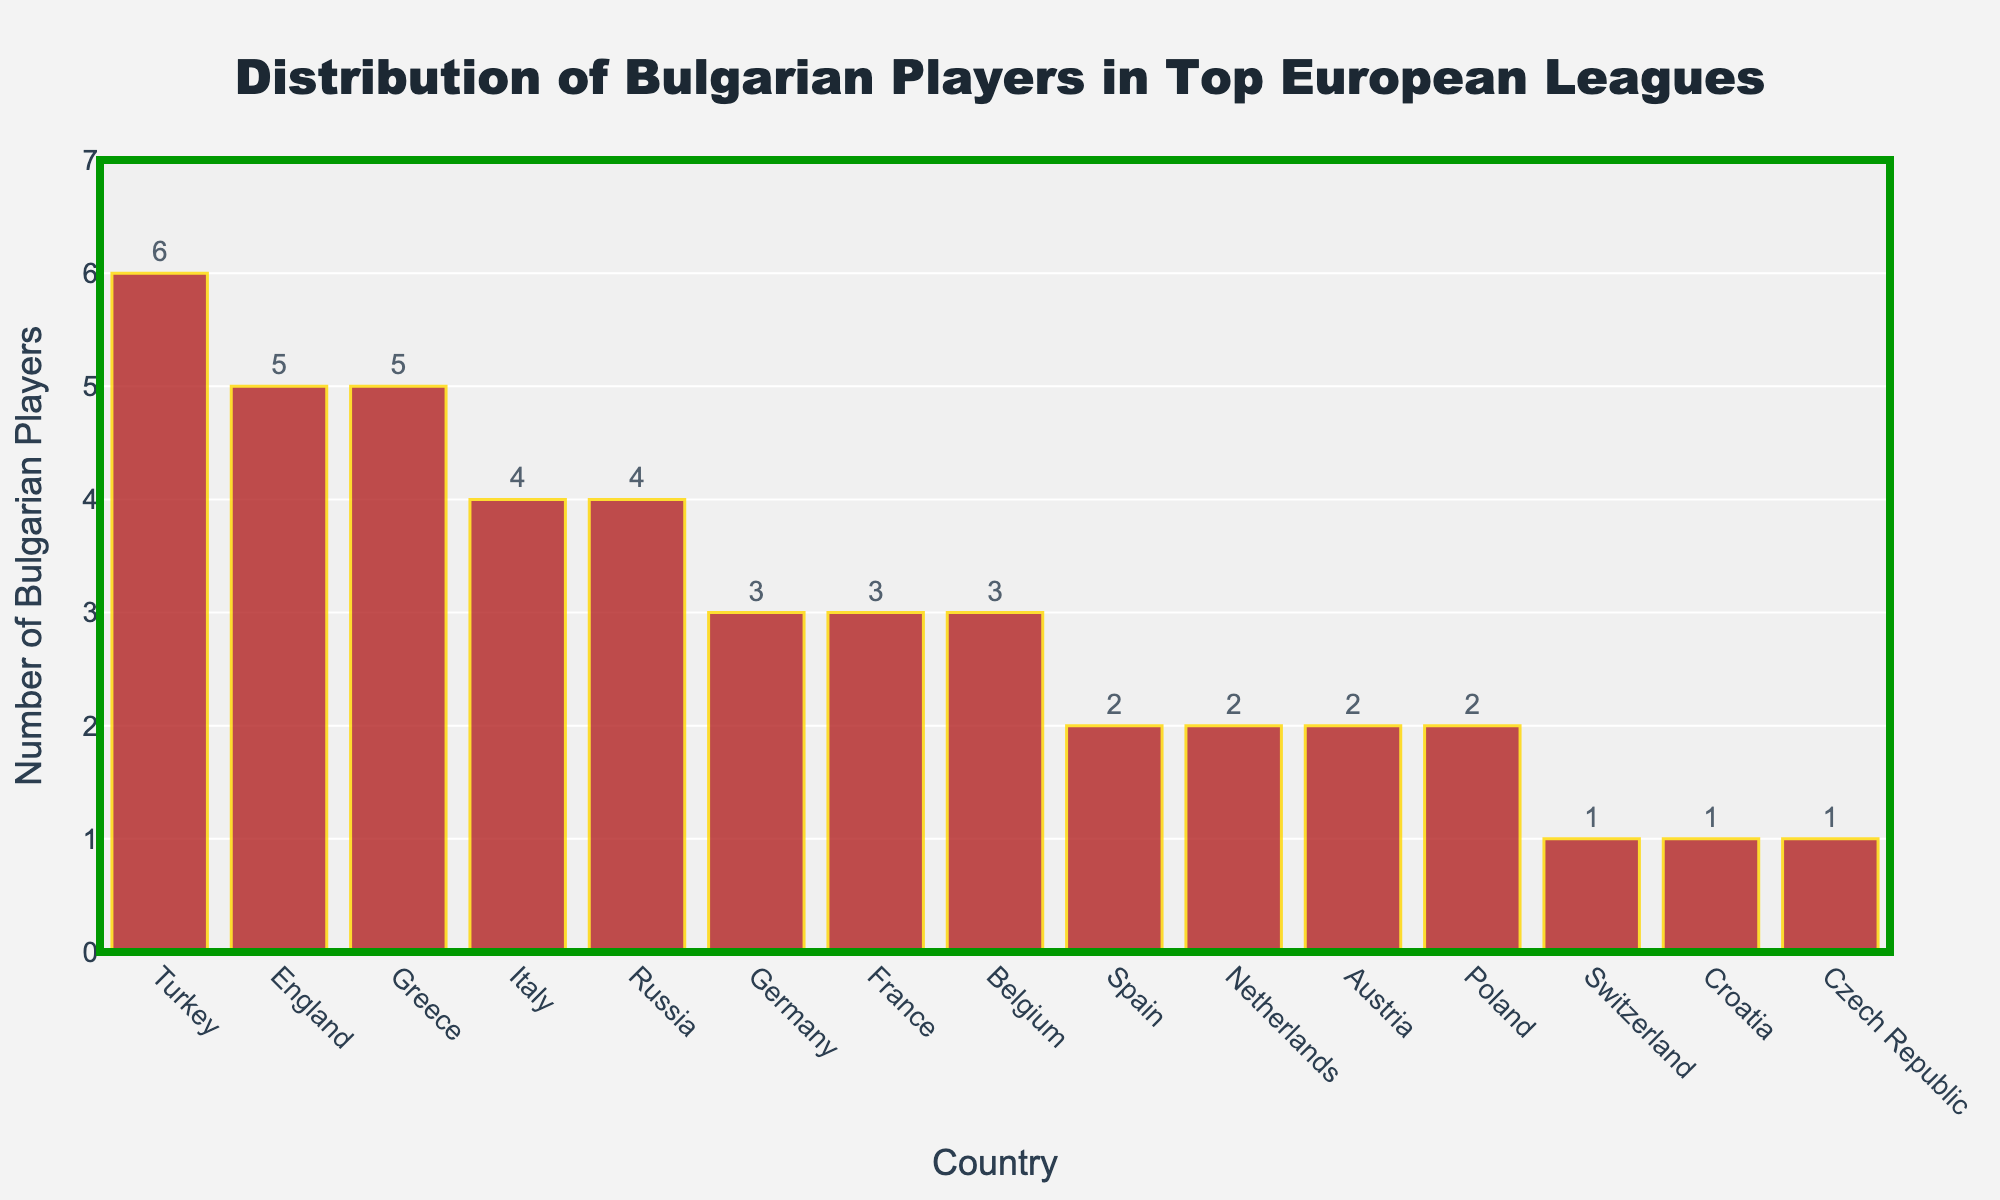what is the total number of Bulgarian players in all the leagues combined? To find the total number of Bulgarian players, sum the values of the "Number of Bulgarian Players" for each country. This is 5 (England) + 3 (Germany) + 4 (Italy) + 2 (Spain) + 3 (France) + 2 (Netherlands) + 3 (Belgium) + 6 (Turkey) + 4 (Russia) + 5 (Greece) + 2 (Austria) + 1 (Switzerland) + 2 (Poland) + 1 (Croatia) + 1 (Czech Republic) = 44
Answer: 44 which country has the highest number of Bulgarian players? By looking at the height of the bars and reading the values, the country with the tallest bar is the one with the highest number of Bulgarian players. In this case, that country is Turkey with 6 players.
Answer: Turkey how many countries have exactly 3 Bulgarian players? Count the number of bars (countries) that have a height corresponding to the value 3. These countries are Germany, France, and Belgium. Hence, there are 3 countries.
Answer: 3 which countries have fewer than 2 Bulgarian players? Identify the countries with bars shorter than the value representing 2 players. These countries are Switzerland, Croatia, and Czech Republic.
Answer: Switzerland, Croatia, Czech Republic what is the difference between the number of Bulgarian players in England and Greece? The number of Bulgarian players in England is 5, and in Greece, it is 5. The difference is thus 5 - 5 = 0
Answer: 0 which countries have more Bulgarian players than Spain but fewer than England? Spain has 2 Bulgarian players, and England has 5. The countries falling between these values are Italy (4), Russia (4), Germany (3), France (3), Belgium (3), and Greece (5).
Answer: Italy, Russia, Germany, France, Belgium, Greece what is the average number of Bulgarian players across all countries? To find the average, sum the total number of Bulgarian players and divide by the number of countries. The total is 44 players across 15 countries, so the average is 44 / 15 ≈ 2.93
Answer: ≈2.93 what is the height difference between the bars representing Italy and Netherlands? The number of Bulgarian players in Italy is 4, and in the Netherlands, it is 2. The height difference is 4 - 2 = 2
Answer: 2 which country has the least number of Bulgarian players in the top European leagues? By visually inspecting the bars, the country with the shortest bar is Switzerland with 1 player.
Answer: Switzerland what is the combined total of Bulgarian players in the three countries with the most players? The three countries with the most Bulgarian players are Turkey (6), England (5), and Greece (5). The combined total of players in these countries is 6 + 5 + 5 = 16
Answer: 16 